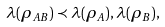Convert formula to latex. <formula><loc_0><loc_0><loc_500><loc_500>\lambda ( \rho _ { A B } ) \prec \lambda ( \rho _ { A } ) , \lambda ( \rho _ { B } ) ,</formula> 